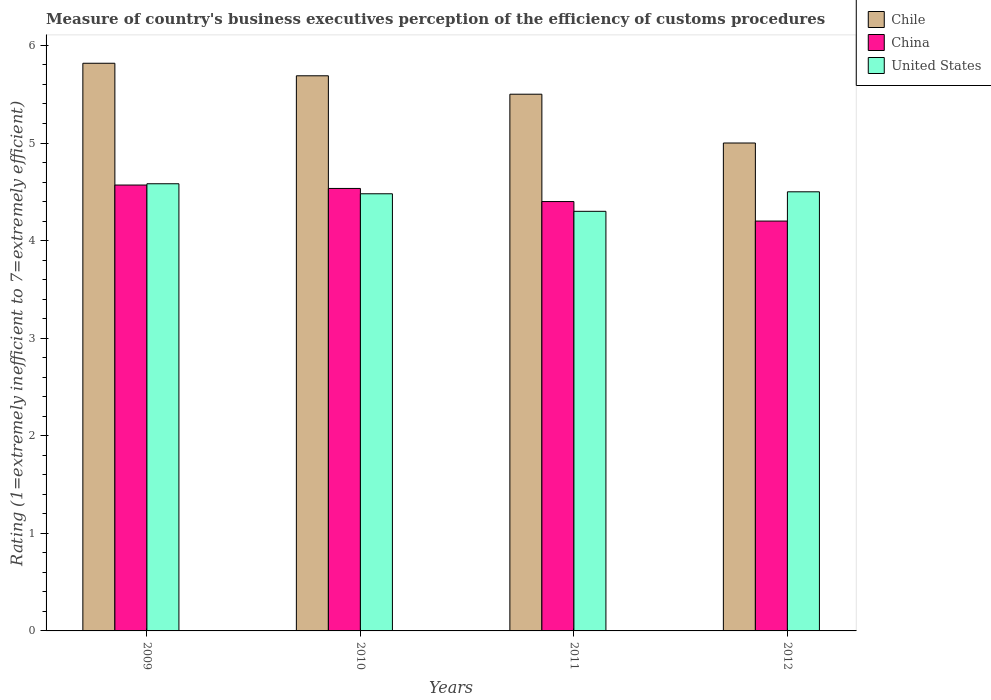How many different coloured bars are there?
Make the answer very short. 3. How many groups of bars are there?
Make the answer very short. 4. Are the number of bars on each tick of the X-axis equal?
Offer a terse response. Yes. What is the rating of the efficiency of customs procedure in Chile in 2009?
Offer a very short reply. 5.82. Across all years, what is the maximum rating of the efficiency of customs procedure in Chile?
Ensure brevity in your answer.  5.82. Across all years, what is the minimum rating of the efficiency of customs procedure in China?
Offer a terse response. 4.2. What is the total rating of the efficiency of customs procedure in United States in the graph?
Keep it short and to the point. 17.86. What is the difference between the rating of the efficiency of customs procedure in China in 2010 and that in 2011?
Your answer should be very brief. 0.13. What is the difference between the rating of the efficiency of customs procedure in Chile in 2011 and the rating of the efficiency of customs procedure in China in 2010?
Your answer should be very brief. 0.97. What is the average rating of the efficiency of customs procedure in United States per year?
Make the answer very short. 4.47. In the year 2012, what is the difference between the rating of the efficiency of customs procedure in Chile and rating of the efficiency of customs procedure in United States?
Provide a short and direct response. 0.5. What is the ratio of the rating of the efficiency of customs procedure in China in 2009 to that in 2012?
Make the answer very short. 1.09. What is the difference between the highest and the second highest rating of the efficiency of customs procedure in United States?
Provide a succinct answer. 0.08. What is the difference between the highest and the lowest rating of the efficiency of customs procedure in Chile?
Your response must be concise. 0.82. How many bars are there?
Your answer should be compact. 12. How many years are there in the graph?
Offer a terse response. 4. Does the graph contain any zero values?
Provide a succinct answer. No. Does the graph contain grids?
Give a very brief answer. No. Where does the legend appear in the graph?
Your answer should be very brief. Top right. How are the legend labels stacked?
Provide a short and direct response. Vertical. What is the title of the graph?
Give a very brief answer. Measure of country's business executives perception of the efficiency of customs procedures. What is the label or title of the Y-axis?
Offer a very short reply. Rating (1=extremely inefficient to 7=extremely efficient). What is the Rating (1=extremely inefficient to 7=extremely efficient) of Chile in 2009?
Your answer should be compact. 5.82. What is the Rating (1=extremely inefficient to 7=extremely efficient) of China in 2009?
Your answer should be very brief. 4.57. What is the Rating (1=extremely inefficient to 7=extremely efficient) in United States in 2009?
Give a very brief answer. 4.58. What is the Rating (1=extremely inefficient to 7=extremely efficient) of Chile in 2010?
Keep it short and to the point. 5.69. What is the Rating (1=extremely inefficient to 7=extremely efficient) in China in 2010?
Your answer should be compact. 4.53. What is the Rating (1=extremely inefficient to 7=extremely efficient) of United States in 2010?
Your response must be concise. 4.48. What is the Rating (1=extremely inefficient to 7=extremely efficient) in Chile in 2011?
Provide a succinct answer. 5.5. What is the Rating (1=extremely inefficient to 7=extremely efficient) in China in 2011?
Your response must be concise. 4.4. What is the Rating (1=extremely inefficient to 7=extremely efficient) in United States in 2011?
Provide a short and direct response. 4.3. What is the Rating (1=extremely inefficient to 7=extremely efficient) in Chile in 2012?
Offer a very short reply. 5. Across all years, what is the maximum Rating (1=extremely inefficient to 7=extremely efficient) of Chile?
Your answer should be very brief. 5.82. Across all years, what is the maximum Rating (1=extremely inefficient to 7=extremely efficient) of China?
Your answer should be very brief. 4.57. Across all years, what is the maximum Rating (1=extremely inefficient to 7=extremely efficient) of United States?
Your answer should be very brief. 4.58. Across all years, what is the minimum Rating (1=extremely inefficient to 7=extremely efficient) in Chile?
Offer a very short reply. 5. What is the total Rating (1=extremely inefficient to 7=extremely efficient) of Chile in the graph?
Provide a short and direct response. 22.01. What is the total Rating (1=extremely inefficient to 7=extremely efficient) in China in the graph?
Your answer should be very brief. 17.7. What is the total Rating (1=extremely inefficient to 7=extremely efficient) of United States in the graph?
Ensure brevity in your answer.  17.86. What is the difference between the Rating (1=extremely inefficient to 7=extremely efficient) in Chile in 2009 and that in 2010?
Give a very brief answer. 0.13. What is the difference between the Rating (1=extremely inefficient to 7=extremely efficient) in China in 2009 and that in 2010?
Give a very brief answer. 0.03. What is the difference between the Rating (1=extremely inefficient to 7=extremely efficient) in United States in 2009 and that in 2010?
Offer a terse response. 0.1. What is the difference between the Rating (1=extremely inefficient to 7=extremely efficient) in Chile in 2009 and that in 2011?
Your response must be concise. 0.32. What is the difference between the Rating (1=extremely inefficient to 7=extremely efficient) in China in 2009 and that in 2011?
Make the answer very short. 0.17. What is the difference between the Rating (1=extremely inefficient to 7=extremely efficient) in United States in 2009 and that in 2011?
Keep it short and to the point. 0.28. What is the difference between the Rating (1=extremely inefficient to 7=extremely efficient) of Chile in 2009 and that in 2012?
Keep it short and to the point. 0.82. What is the difference between the Rating (1=extremely inefficient to 7=extremely efficient) in China in 2009 and that in 2012?
Give a very brief answer. 0.37. What is the difference between the Rating (1=extremely inefficient to 7=extremely efficient) of United States in 2009 and that in 2012?
Your response must be concise. 0.08. What is the difference between the Rating (1=extremely inefficient to 7=extremely efficient) in Chile in 2010 and that in 2011?
Provide a succinct answer. 0.19. What is the difference between the Rating (1=extremely inefficient to 7=extremely efficient) in China in 2010 and that in 2011?
Provide a succinct answer. 0.13. What is the difference between the Rating (1=extremely inefficient to 7=extremely efficient) in United States in 2010 and that in 2011?
Ensure brevity in your answer.  0.18. What is the difference between the Rating (1=extremely inefficient to 7=extremely efficient) of Chile in 2010 and that in 2012?
Your answer should be very brief. 0.69. What is the difference between the Rating (1=extremely inefficient to 7=extremely efficient) of China in 2010 and that in 2012?
Your answer should be compact. 0.33. What is the difference between the Rating (1=extremely inefficient to 7=extremely efficient) in United States in 2010 and that in 2012?
Your response must be concise. -0.02. What is the difference between the Rating (1=extremely inefficient to 7=extremely efficient) of China in 2011 and that in 2012?
Your answer should be very brief. 0.2. What is the difference between the Rating (1=extremely inefficient to 7=extremely efficient) of United States in 2011 and that in 2012?
Your response must be concise. -0.2. What is the difference between the Rating (1=extremely inefficient to 7=extremely efficient) in Chile in 2009 and the Rating (1=extremely inefficient to 7=extremely efficient) in China in 2010?
Make the answer very short. 1.28. What is the difference between the Rating (1=extremely inefficient to 7=extremely efficient) in Chile in 2009 and the Rating (1=extremely inefficient to 7=extremely efficient) in United States in 2010?
Make the answer very short. 1.34. What is the difference between the Rating (1=extremely inefficient to 7=extremely efficient) in China in 2009 and the Rating (1=extremely inefficient to 7=extremely efficient) in United States in 2010?
Offer a very short reply. 0.09. What is the difference between the Rating (1=extremely inefficient to 7=extremely efficient) in Chile in 2009 and the Rating (1=extremely inefficient to 7=extremely efficient) in China in 2011?
Provide a short and direct response. 1.42. What is the difference between the Rating (1=extremely inefficient to 7=extremely efficient) in Chile in 2009 and the Rating (1=extremely inefficient to 7=extremely efficient) in United States in 2011?
Offer a terse response. 1.52. What is the difference between the Rating (1=extremely inefficient to 7=extremely efficient) in China in 2009 and the Rating (1=extremely inefficient to 7=extremely efficient) in United States in 2011?
Provide a short and direct response. 0.27. What is the difference between the Rating (1=extremely inefficient to 7=extremely efficient) of Chile in 2009 and the Rating (1=extremely inefficient to 7=extremely efficient) of China in 2012?
Ensure brevity in your answer.  1.62. What is the difference between the Rating (1=extremely inefficient to 7=extremely efficient) in Chile in 2009 and the Rating (1=extremely inefficient to 7=extremely efficient) in United States in 2012?
Keep it short and to the point. 1.32. What is the difference between the Rating (1=extremely inefficient to 7=extremely efficient) in China in 2009 and the Rating (1=extremely inefficient to 7=extremely efficient) in United States in 2012?
Give a very brief answer. 0.07. What is the difference between the Rating (1=extremely inefficient to 7=extremely efficient) of Chile in 2010 and the Rating (1=extremely inefficient to 7=extremely efficient) of China in 2011?
Offer a terse response. 1.29. What is the difference between the Rating (1=extremely inefficient to 7=extremely efficient) in Chile in 2010 and the Rating (1=extremely inefficient to 7=extremely efficient) in United States in 2011?
Your response must be concise. 1.39. What is the difference between the Rating (1=extremely inefficient to 7=extremely efficient) of China in 2010 and the Rating (1=extremely inefficient to 7=extremely efficient) of United States in 2011?
Provide a succinct answer. 0.23. What is the difference between the Rating (1=extremely inefficient to 7=extremely efficient) in Chile in 2010 and the Rating (1=extremely inefficient to 7=extremely efficient) in China in 2012?
Offer a very short reply. 1.49. What is the difference between the Rating (1=extremely inefficient to 7=extremely efficient) in Chile in 2010 and the Rating (1=extremely inefficient to 7=extremely efficient) in United States in 2012?
Make the answer very short. 1.19. What is the difference between the Rating (1=extremely inefficient to 7=extremely efficient) in China in 2010 and the Rating (1=extremely inefficient to 7=extremely efficient) in United States in 2012?
Your answer should be compact. 0.03. What is the difference between the Rating (1=extremely inefficient to 7=extremely efficient) of China in 2011 and the Rating (1=extremely inefficient to 7=extremely efficient) of United States in 2012?
Your answer should be very brief. -0.1. What is the average Rating (1=extremely inefficient to 7=extremely efficient) of Chile per year?
Keep it short and to the point. 5.5. What is the average Rating (1=extremely inefficient to 7=extremely efficient) in China per year?
Ensure brevity in your answer.  4.43. What is the average Rating (1=extremely inefficient to 7=extremely efficient) of United States per year?
Offer a terse response. 4.47. In the year 2009, what is the difference between the Rating (1=extremely inefficient to 7=extremely efficient) in Chile and Rating (1=extremely inefficient to 7=extremely efficient) in China?
Your answer should be very brief. 1.25. In the year 2009, what is the difference between the Rating (1=extremely inefficient to 7=extremely efficient) in Chile and Rating (1=extremely inefficient to 7=extremely efficient) in United States?
Keep it short and to the point. 1.23. In the year 2009, what is the difference between the Rating (1=extremely inefficient to 7=extremely efficient) of China and Rating (1=extremely inefficient to 7=extremely efficient) of United States?
Offer a terse response. -0.01. In the year 2010, what is the difference between the Rating (1=extremely inefficient to 7=extremely efficient) of Chile and Rating (1=extremely inefficient to 7=extremely efficient) of China?
Make the answer very short. 1.15. In the year 2010, what is the difference between the Rating (1=extremely inefficient to 7=extremely efficient) of Chile and Rating (1=extremely inefficient to 7=extremely efficient) of United States?
Make the answer very short. 1.21. In the year 2010, what is the difference between the Rating (1=extremely inefficient to 7=extremely efficient) in China and Rating (1=extremely inefficient to 7=extremely efficient) in United States?
Offer a terse response. 0.05. In the year 2011, what is the difference between the Rating (1=extremely inefficient to 7=extremely efficient) of China and Rating (1=extremely inefficient to 7=extremely efficient) of United States?
Keep it short and to the point. 0.1. In the year 2012, what is the difference between the Rating (1=extremely inefficient to 7=extremely efficient) in China and Rating (1=extremely inefficient to 7=extremely efficient) in United States?
Give a very brief answer. -0.3. What is the ratio of the Rating (1=extremely inefficient to 7=extremely efficient) in Chile in 2009 to that in 2010?
Provide a short and direct response. 1.02. What is the ratio of the Rating (1=extremely inefficient to 7=extremely efficient) in China in 2009 to that in 2010?
Ensure brevity in your answer.  1.01. What is the ratio of the Rating (1=extremely inefficient to 7=extremely efficient) in United States in 2009 to that in 2010?
Make the answer very short. 1.02. What is the ratio of the Rating (1=extremely inefficient to 7=extremely efficient) in Chile in 2009 to that in 2011?
Your answer should be very brief. 1.06. What is the ratio of the Rating (1=extremely inefficient to 7=extremely efficient) in China in 2009 to that in 2011?
Your response must be concise. 1.04. What is the ratio of the Rating (1=extremely inefficient to 7=extremely efficient) in United States in 2009 to that in 2011?
Offer a terse response. 1.07. What is the ratio of the Rating (1=extremely inefficient to 7=extremely efficient) of Chile in 2009 to that in 2012?
Your answer should be very brief. 1.16. What is the ratio of the Rating (1=extremely inefficient to 7=extremely efficient) in China in 2009 to that in 2012?
Offer a terse response. 1.09. What is the ratio of the Rating (1=extremely inefficient to 7=extremely efficient) of United States in 2009 to that in 2012?
Offer a terse response. 1.02. What is the ratio of the Rating (1=extremely inefficient to 7=extremely efficient) of Chile in 2010 to that in 2011?
Your response must be concise. 1.03. What is the ratio of the Rating (1=extremely inefficient to 7=extremely efficient) in China in 2010 to that in 2011?
Offer a very short reply. 1.03. What is the ratio of the Rating (1=extremely inefficient to 7=extremely efficient) in United States in 2010 to that in 2011?
Offer a very short reply. 1.04. What is the ratio of the Rating (1=extremely inefficient to 7=extremely efficient) in Chile in 2010 to that in 2012?
Your response must be concise. 1.14. What is the ratio of the Rating (1=extremely inefficient to 7=extremely efficient) in China in 2010 to that in 2012?
Offer a terse response. 1.08. What is the ratio of the Rating (1=extremely inefficient to 7=extremely efficient) of United States in 2010 to that in 2012?
Offer a terse response. 1. What is the ratio of the Rating (1=extremely inefficient to 7=extremely efficient) in China in 2011 to that in 2012?
Offer a very short reply. 1.05. What is the ratio of the Rating (1=extremely inefficient to 7=extremely efficient) in United States in 2011 to that in 2012?
Make the answer very short. 0.96. What is the difference between the highest and the second highest Rating (1=extremely inefficient to 7=extremely efficient) in Chile?
Ensure brevity in your answer.  0.13. What is the difference between the highest and the second highest Rating (1=extremely inefficient to 7=extremely efficient) in China?
Provide a short and direct response. 0.03. What is the difference between the highest and the second highest Rating (1=extremely inefficient to 7=extremely efficient) in United States?
Provide a short and direct response. 0.08. What is the difference between the highest and the lowest Rating (1=extremely inefficient to 7=extremely efficient) of Chile?
Your answer should be very brief. 0.82. What is the difference between the highest and the lowest Rating (1=extremely inefficient to 7=extremely efficient) in China?
Your answer should be very brief. 0.37. What is the difference between the highest and the lowest Rating (1=extremely inefficient to 7=extremely efficient) in United States?
Keep it short and to the point. 0.28. 